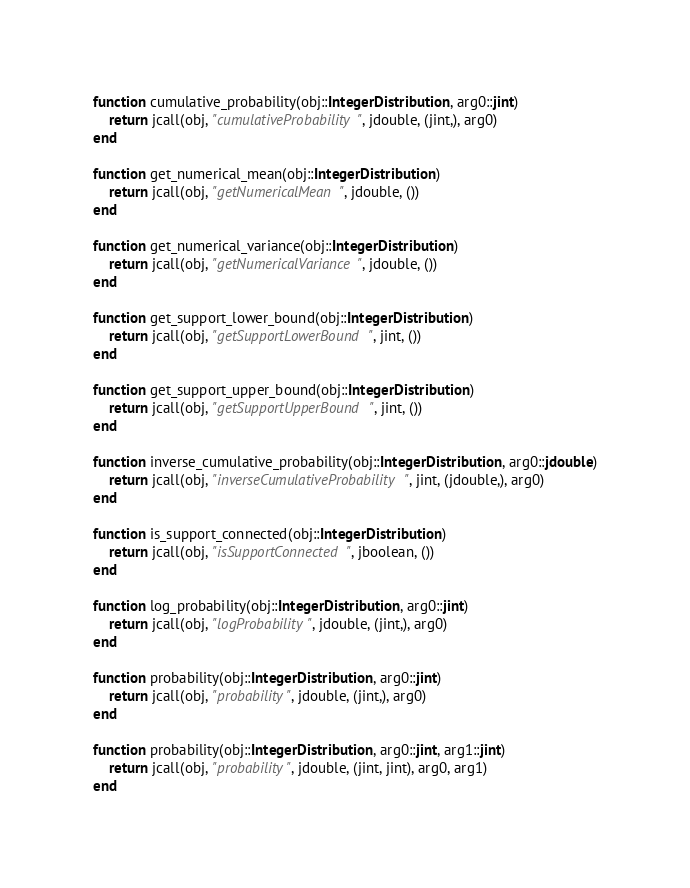Convert code to text. <code><loc_0><loc_0><loc_500><loc_500><_Julia_>function cumulative_probability(obj::IntegerDistribution, arg0::jint)
    return jcall(obj, "cumulativeProbability", jdouble, (jint,), arg0)
end

function get_numerical_mean(obj::IntegerDistribution)
    return jcall(obj, "getNumericalMean", jdouble, ())
end

function get_numerical_variance(obj::IntegerDistribution)
    return jcall(obj, "getNumericalVariance", jdouble, ())
end

function get_support_lower_bound(obj::IntegerDistribution)
    return jcall(obj, "getSupportLowerBound", jint, ())
end

function get_support_upper_bound(obj::IntegerDistribution)
    return jcall(obj, "getSupportUpperBound", jint, ())
end

function inverse_cumulative_probability(obj::IntegerDistribution, arg0::jdouble)
    return jcall(obj, "inverseCumulativeProbability", jint, (jdouble,), arg0)
end

function is_support_connected(obj::IntegerDistribution)
    return jcall(obj, "isSupportConnected", jboolean, ())
end

function log_probability(obj::IntegerDistribution, arg0::jint)
    return jcall(obj, "logProbability", jdouble, (jint,), arg0)
end

function probability(obj::IntegerDistribution, arg0::jint)
    return jcall(obj, "probability", jdouble, (jint,), arg0)
end

function probability(obj::IntegerDistribution, arg0::jint, arg1::jint)
    return jcall(obj, "probability", jdouble, (jint, jint), arg0, arg1)
end

</code> 